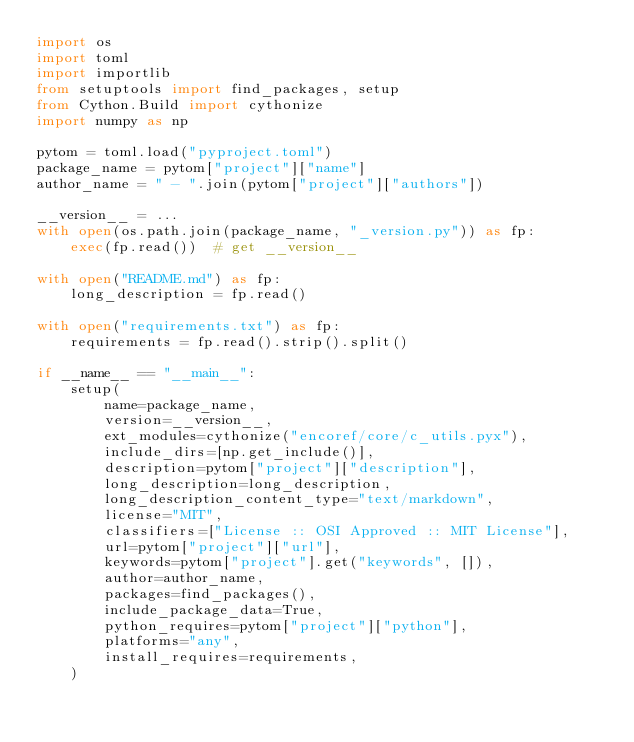<code> <loc_0><loc_0><loc_500><loc_500><_Python_>import os
import toml
import importlib
from setuptools import find_packages, setup
from Cython.Build import cythonize
import numpy as np

pytom = toml.load("pyproject.toml")
package_name = pytom["project"]["name"]
author_name = " - ".join(pytom["project"]["authors"])

__version__ = ...
with open(os.path.join(package_name, "_version.py")) as fp:
    exec(fp.read())  # get __version__

with open("README.md") as fp:
    long_description = fp.read()

with open("requirements.txt") as fp:
    requirements = fp.read().strip().split()

if __name__ == "__main__":
    setup(
        name=package_name,
        version=__version__,
        ext_modules=cythonize("encoref/core/c_utils.pyx"),
        include_dirs=[np.get_include()],
        description=pytom["project"]["description"],
        long_description=long_description,
        long_description_content_type="text/markdown",
        license="MIT",
        classifiers=["License :: OSI Approved :: MIT License"],
        url=pytom["project"]["url"],
        keywords=pytom["project"].get("keywords", []),
        author=author_name,
        packages=find_packages(),
        include_package_data=True,
        python_requires=pytom["project"]["python"],
        platforms="any",
        install_requires=requirements,
    )
</code> 